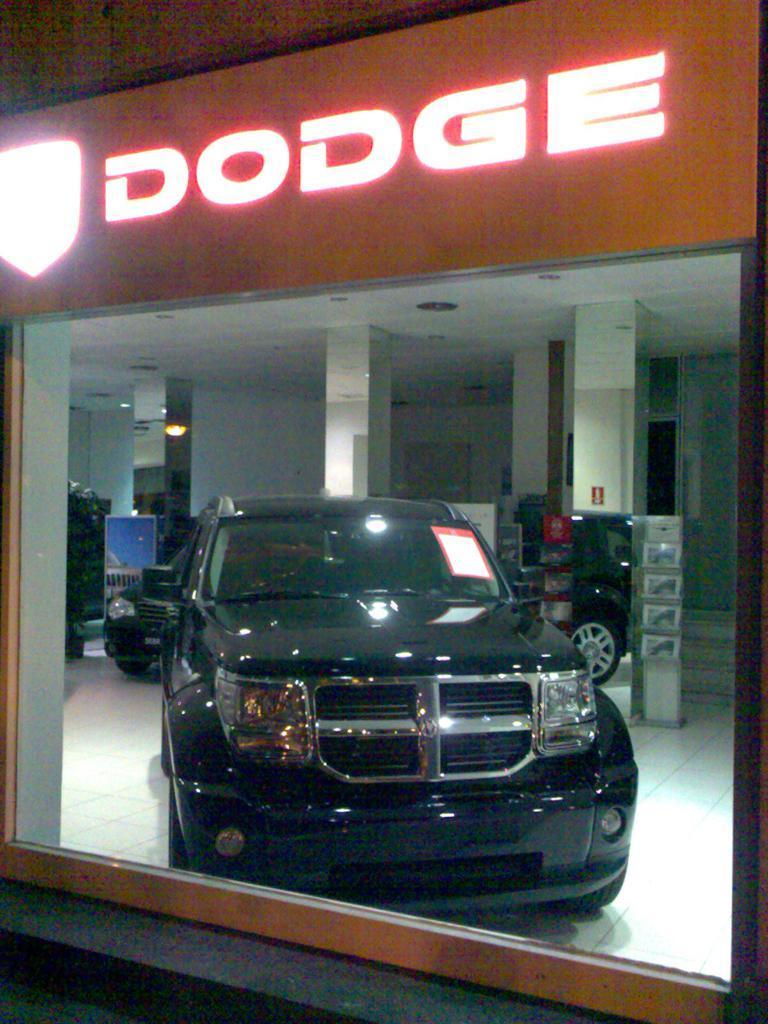Could you give a brief overview of what you see in this image? In the center of the image there is a black color car. 